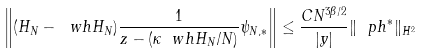Convert formula to latex. <formula><loc_0><loc_0><loc_500><loc_500>\left \| ( H _ { N } - \ w h H _ { N } ) \frac { 1 } { z - ( \kappa \ w h H _ { N } / N ) } \psi _ { N , * } \right \| \leq \frac { C N ^ { 3 \beta / 2 } } { | y | } \| \ p h ^ { * } \| _ { H ^ { 2 } }</formula> 